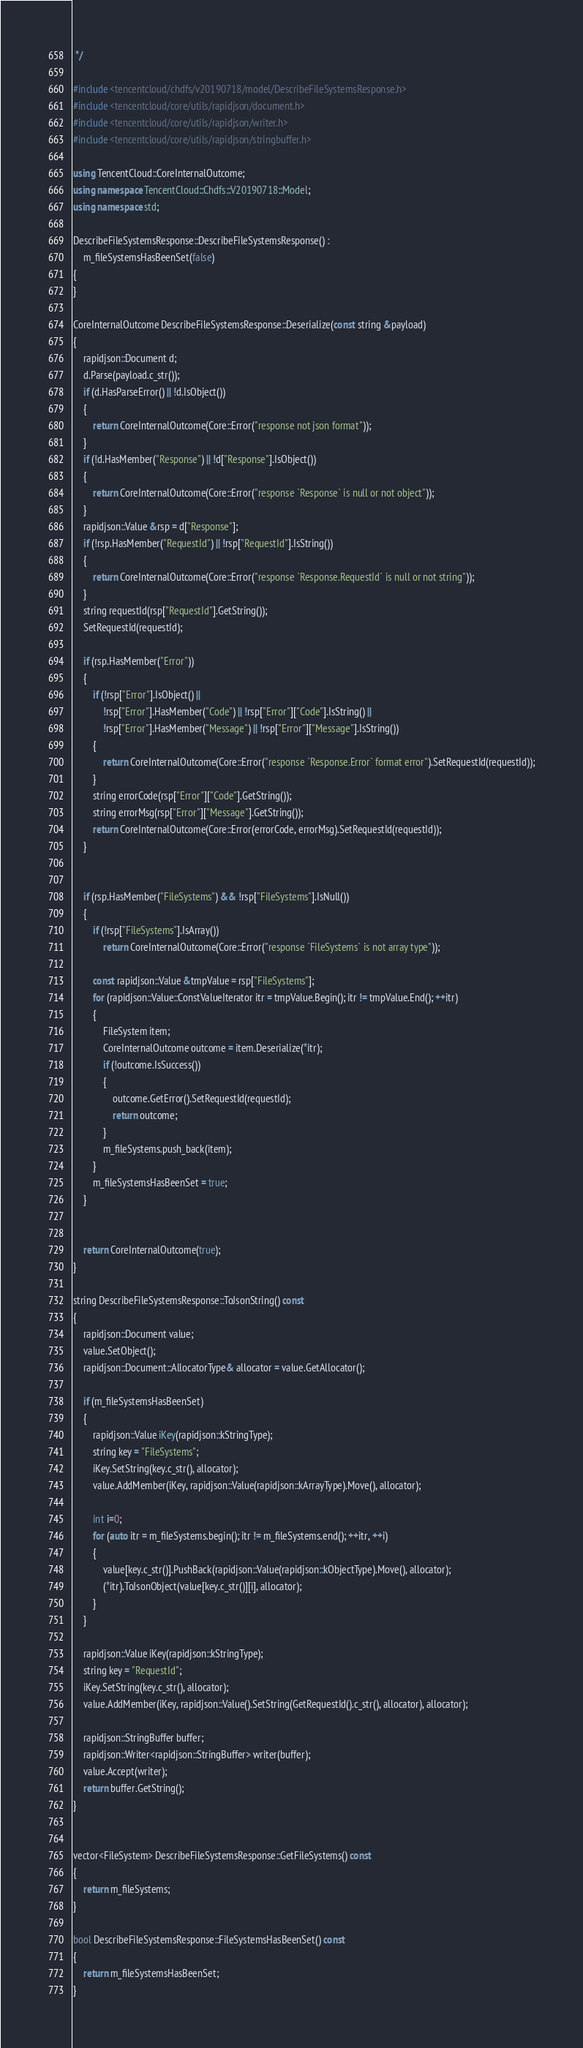<code> <loc_0><loc_0><loc_500><loc_500><_C++_> */

#include <tencentcloud/chdfs/v20190718/model/DescribeFileSystemsResponse.h>
#include <tencentcloud/core/utils/rapidjson/document.h>
#include <tencentcloud/core/utils/rapidjson/writer.h>
#include <tencentcloud/core/utils/rapidjson/stringbuffer.h>

using TencentCloud::CoreInternalOutcome;
using namespace TencentCloud::Chdfs::V20190718::Model;
using namespace std;

DescribeFileSystemsResponse::DescribeFileSystemsResponse() :
    m_fileSystemsHasBeenSet(false)
{
}

CoreInternalOutcome DescribeFileSystemsResponse::Deserialize(const string &payload)
{
    rapidjson::Document d;
    d.Parse(payload.c_str());
    if (d.HasParseError() || !d.IsObject())
    {
        return CoreInternalOutcome(Core::Error("response not json format"));
    }
    if (!d.HasMember("Response") || !d["Response"].IsObject())
    {
        return CoreInternalOutcome(Core::Error("response `Response` is null or not object"));
    }
    rapidjson::Value &rsp = d["Response"];
    if (!rsp.HasMember("RequestId") || !rsp["RequestId"].IsString())
    {
        return CoreInternalOutcome(Core::Error("response `Response.RequestId` is null or not string"));
    }
    string requestId(rsp["RequestId"].GetString());
    SetRequestId(requestId);

    if (rsp.HasMember("Error"))
    {
        if (!rsp["Error"].IsObject() ||
            !rsp["Error"].HasMember("Code") || !rsp["Error"]["Code"].IsString() ||
            !rsp["Error"].HasMember("Message") || !rsp["Error"]["Message"].IsString())
        {
            return CoreInternalOutcome(Core::Error("response `Response.Error` format error").SetRequestId(requestId));
        }
        string errorCode(rsp["Error"]["Code"].GetString());
        string errorMsg(rsp["Error"]["Message"].GetString());
        return CoreInternalOutcome(Core::Error(errorCode, errorMsg).SetRequestId(requestId));
    }


    if (rsp.HasMember("FileSystems") && !rsp["FileSystems"].IsNull())
    {
        if (!rsp["FileSystems"].IsArray())
            return CoreInternalOutcome(Core::Error("response `FileSystems` is not array type"));

        const rapidjson::Value &tmpValue = rsp["FileSystems"];
        for (rapidjson::Value::ConstValueIterator itr = tmpValue.Begin(); itr != tmpValue.End(); ++itr)
        {
            FileSystem item;
            CoreInternalOutcome outcome = item.Deserialize(*itr);
            if (!outcome.IsSuccess())
            {
                outcome.GetError().SetRequestId(requestId);
                return outcome;
            }
            m_fileSystems.push_back(item);
        }
        m_fileSystemsHasBeenSet = true;
    }


    return CoreInternalOutcome(true);
}

string DescribeFileSystemsResponse::ToJsonString() const
{
    rapidjson::Document value;
    value.SetObject();
    rapidjson::Document::AllocatorType& allocator = value.GetAllocator();

    if (m_fileSystemsHasBeenSet)
    {
        rapidjson::Value iKey(rapidjson::kStringType);
        string key = "FileSystems";
        iKey.SetString(key.c_str(), allocator);
        value.AddMember(iKey, rapidjson::Value(rapidjson::kArrayType).Move(), allocator);

        int i=0;
        for (auto itr = m_fileSystems.begin(); itr != m_fileSystems.end(); ++itr, ++i)
        {
            value[key.c_str()].PushBack(rapidjson::Value(rapidjson::kObjectType).Move(), allocator);
            (*itr).ToJsonObject(value[key.c_str()][i], allocator);
        }
    }

    rapidjson::Value iKey(rapidjson::kStringType);
    string key = "RequestId";
    iKey.SetString(key.c_str(), allocator);
    value.AddMember(iKey, rapidjson::Value().SetString(GetRequestId().c_str(), allocator), allocator);
    
    rapidjson::StringBuffer buffer;
    rapidjson::Writer<rapidjson::StringBuffer> writer(buffer);
    value.Accept(writer);
    return buffer.GetString();
}


vector<FileSystem> DescribeFileSystemsResponse::GetFileSystems() const
{
    return m_fileSystems;
}

bool DescribeFileSystemsResponse::FileSystemsHasBeenSet() const
{
    return m_fileSystemsHasBeenSet;
}


</code> 